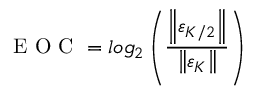Convert formula to latex. <formula><loc_0><loc_0><loc_500><loc_500>E O C = \log _ { 2 } \left ( \frac { \left \| \varepsilon _ { K / 2 } \right \| } { \left \| \varepsilon _ { K } \right \| } \right )</formula> 